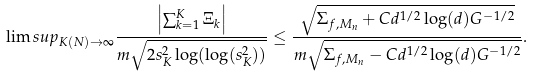<formula> <loc_0><loc_0><loc_500><loc_500>\lim s u p _ { K ( N ) \to \infty } \frac { \left | \sum _ { k = 1 } ^ { K } \Xi _ { k } \right | } { m \sqrt { 2 s _ { K } ^ { 2 } \log ( \log ( s _ { K } ^ { 2 } ) ) } } \leq \frac { \sqrt { \Sigma _ { f , M _ { n } } + C d ^ { 1 / 2 } \log ( d ) G ^ { - 1 / 2 } } } { m \sqrt { \Sigma _ { f , M _ { n } } - C d ^ { 1 / 2 } \log ( d ) G ^ { - 1 / 2 } } } .</formula> 